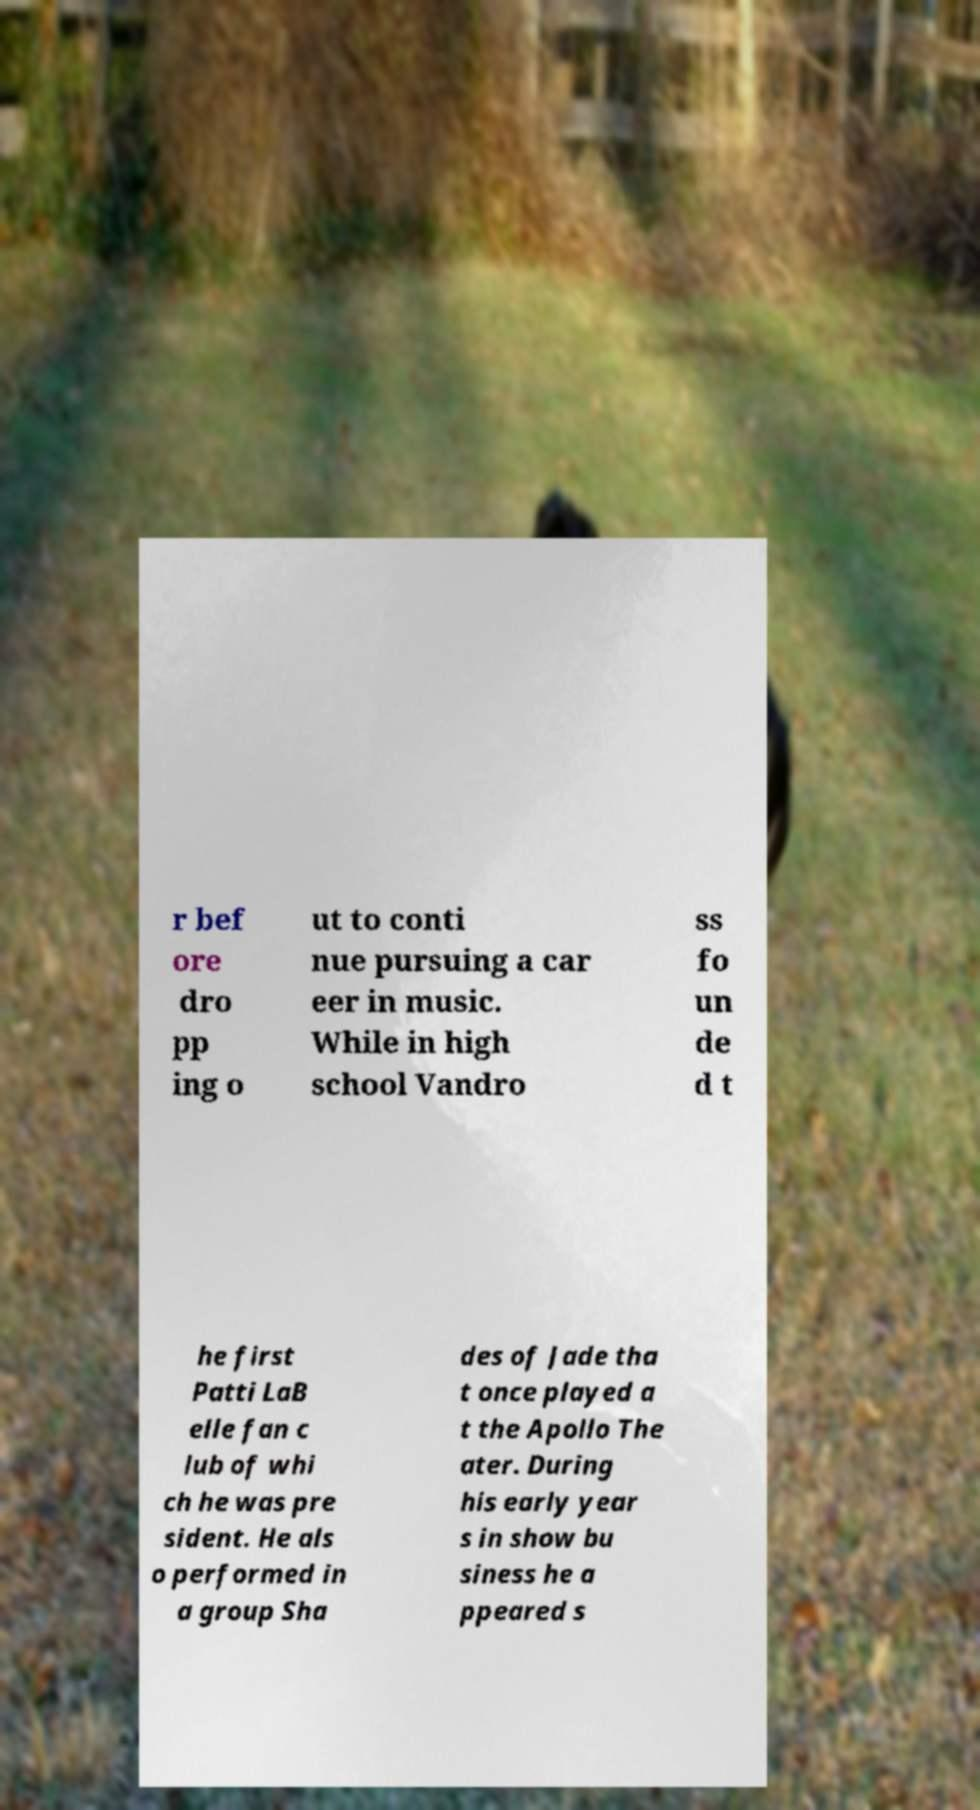There's text embedded in this image that I need extracted. Can you transcribe it verbatim? r bef ore dro pp ing o ut to conti nue pursuing a car eer in music. While in high school Vandro ss fo un de d t he first Patti LaB elle fan c lub of whi ch he was pre sident. He als o performed in a group Sha des of Jade tha t once played a t the Apollo The ater. During his early year s in show bu siness he a ppeared s 